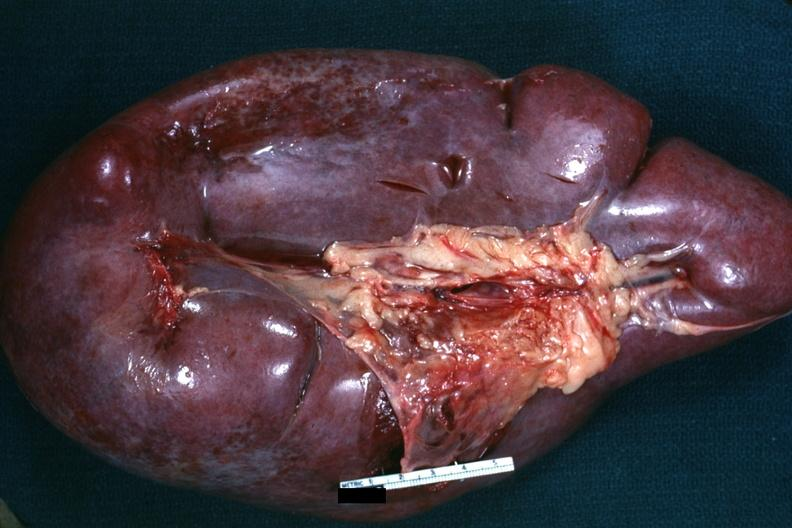where is this part in?
Answer the question using a single word or phrase. Spleen 